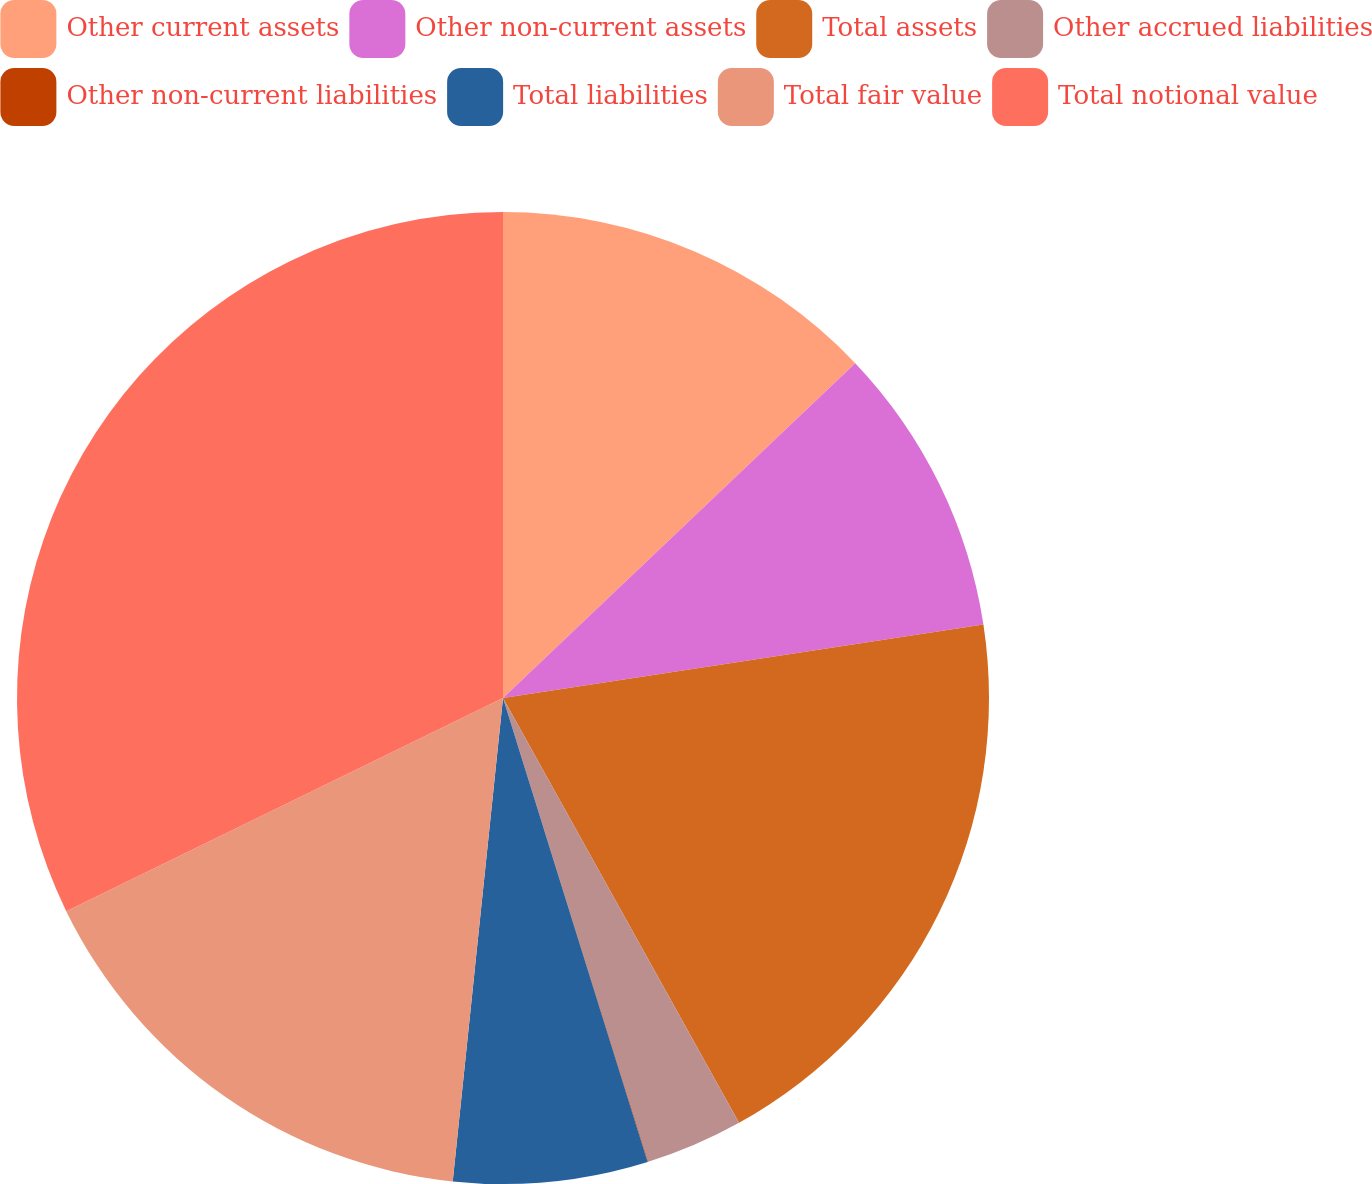Convert chart. <chart><loc_0><loc_0><loc_500><loc_500><pie_chart><fcel>Other current assets<fcel>Other non-current assets<fcel>Total assets<fcel>Other accrued liabilities<fcel>Other non-current liabilities<fcel>Total liabilities<fcel>Total fair value<fcel>Total notional value<nl><fcel>12.9%<fcel>9.68%<fcel>19.34%<fcel>3.24%<fcel>0.02%<fcel>6.46%<fcel>16.12%<fcel>32.22%<nl></chart> 